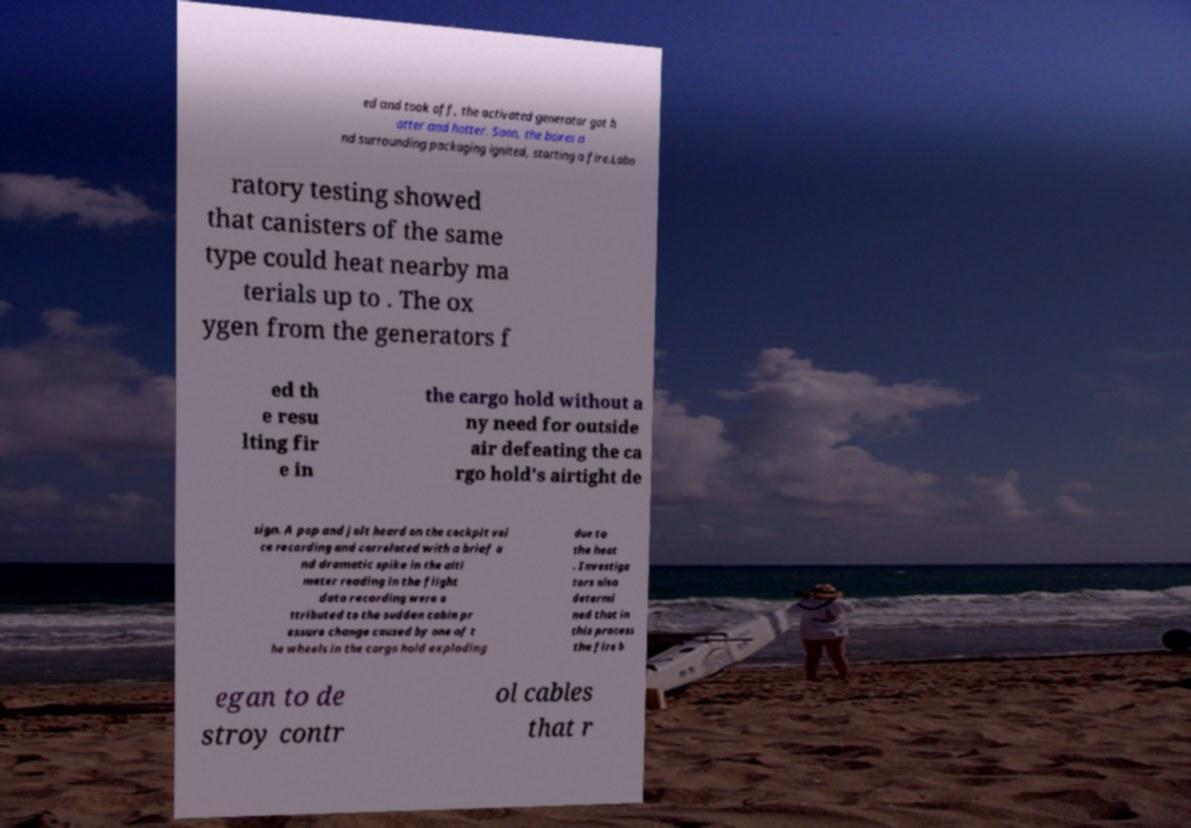For documentation purposes, I need the text within this image transcribed. Could you provide that? ed and took off, the activated generator got h otter and hotter. Soon, the boxes a nd surrounding packaging ignited, starting a fire.Labo ratory testing showed that canisters of the same type could heat nearby ma terials up to . The ox ygen from the generators f ed th e resu lting fir e in the cargo hold without a ny need for outside air defeating the ca rgo hold's airtight de sign. A pop and jolt heard on the cockpit voi ce recording and correlated with a brief a nd dramatic spike in the alti meter reading in the flight data recording were a ttributed to the sudden cabin pr essure change caused by one of t he wheels in the cargo hold exploding due to the heat . Investiga tors also determi ned that in this process the fire b egan to de stroy contr ol cables that r 